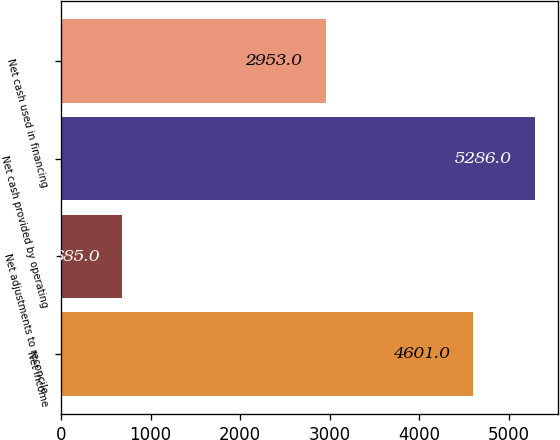Convert chart to OTSL. <chart><loc_0><loc_0><loc_500><loc_500><bar_chart><fcel>Net income<fcel>Net adjustments to reconcile<fcel>Net cash provided by operating<fcel>Net cash used in financing<nl><fcel>4601<fcel>685<fcel>5286<fcel>2953<nl></chart> 